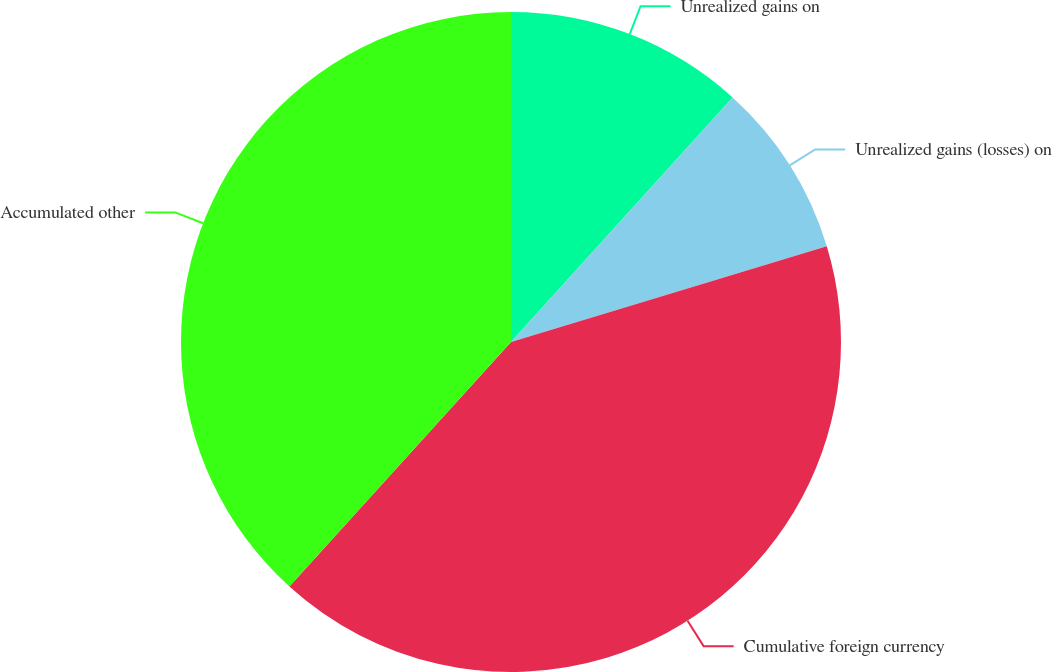Convert chart to OTSL. <chart><loc_0><loc_0><loc_500><loc_500><pie_chart><fcel>Unrealized gains on<fcel>Unrealized gains (losses) on<fcel>Cumulative foreign currency<fcel>Accumulated other<nl><fcel>11.72%<fcel>8.59%<fcel>41.41%<fcel>38.28%<nl></chart> 